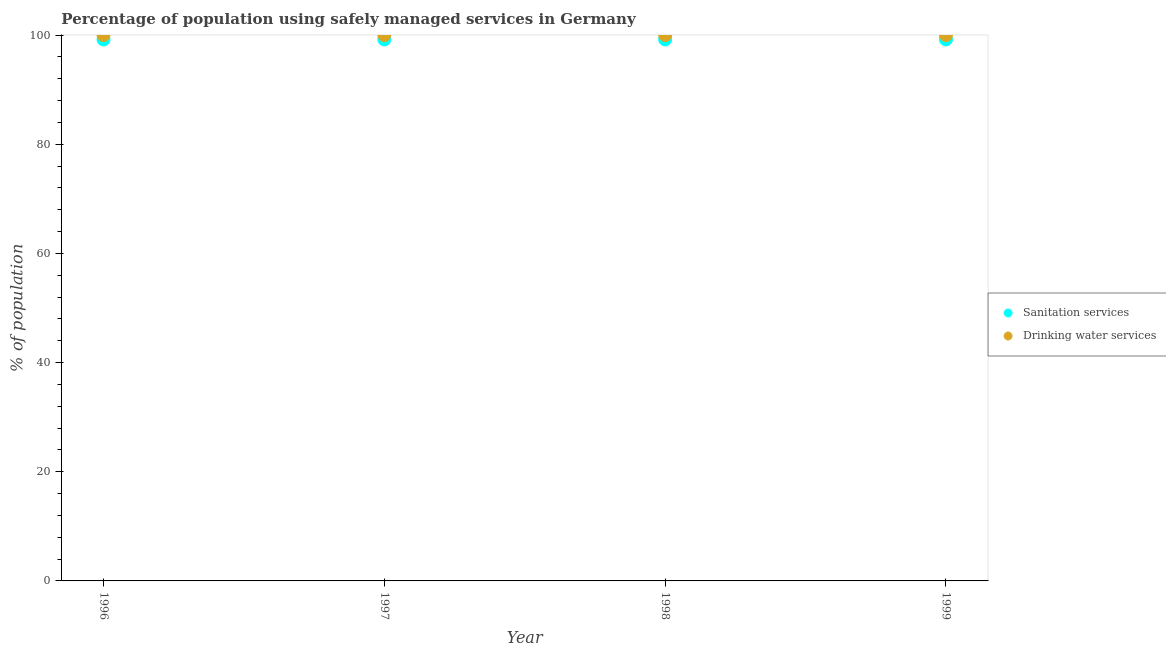What is the percentage of population who used sanitation services in 1998?
Your response must be concise. 99.2. Across all years, what is the maximum percentage of population who used drinking water services?
Your response must be concise. 100. Across all years, what is the minimum percentage of population who used sanitation services?
Make the answer very short. 99.2. What is the total percentage of population who used drinking water services in the graph?
Your answer should be very brief. 400. What is the difference between the percentage of population who used sanitation services in 1998 and that in 1999?
Keep it short and to the point. 0. What is the difference between the percentage of population who used drinking water services in 1997 and the percentage of population who used sanitation services in 1996?
Keep it short and to the point. 0.8. What is the average percentage of population who used sanitation services per year?
Give a very brief answer. 99.2. In the year 1997, what is the difference between the percentage of population who used sanitation services and percentage of population who used drinking water services?
Give a very brief answer. -0.8. In how many years, is the percentage of population who used sanitation services greater than 68 %?
Keep it short and to the point. 4. What is the ratio of the percentage of population who used drinking water services in 1998 to that in 1999?
Your answer should be very brief. 1. Is the percentage of population who used drinking water services in 1996 less than that in 1997?
Ensure brevity in your answer.  No. Is the percentage of population who used drinking water services strictly greater than the percentage of population who used sanitation services over the years?
Make the answer very short. Yes. Is the percentage of population who used drinking water services strictly less than the percentage of population who used sanitation services over the years?
Your answer should be compact. No. How many years are there in the graph?
Give a very brief answer. 4. What is the difference between two consecutive major ticks on the Y-axis?
Your response must be concise. 20. Does the graph contain any zero values?
Your answer should be very brief. No. How many legend labels are there?
Your answer should be compact. 2. What is the title of the graph?
Offer a very short reply. Percentage of population using safely managed services in Germany. Does "National Tourists" appear as one of the legend labels in the graph?
Ensure brevity in your answer.  No. What is the label or title of the Y-axis?
Keep it short and to the point. % of population. What is the % of population of Sanitation services in 1996?
Keep it short and to the point. 99.2. What is the % of population in Drinking water services in 1996?
Offer a very short reply. 100. What is the % of population of Sanitation services in 1997?
Provide a short and direct response. 99.2. What is the % of population of Sanitation services in 1998?
Your response must be concise. 99.2. What is the % of population in Sanitation services in 1999?
Offer a very short reply. 99.2. What is the % of population of Drinking water services in 1999?
Give a very brief answer. 100. Across all years, what is the maximum % of population in Sanitation services?
Keep it short and to the point. 99.2. Across all years, what is the maximum % of population of Drinking water services?
Your answer should be very brief. 100. Across all years, what is the minimum % of population in Sanitation services?
Your response must be concise. 99.2. What is the total % of population in Sanitation services in the graph?
Give a very brief answer. 396.8. What is the total % of population of Drinking water services in the graph?
Ensure brevity in your answer.  400. What is the difference between the % of population of Sanitation services in 1996 and that in 1997?
Keep it short and to the point. 0. What is the difference between the % of population of Drinking water services in 1996 and that in 1997?
Make the answer very short. 0. What is the difference between the % of population of Sanitation services in 1996 and that in 1998?
Ensure brevity in your answer.  0. What is the difference between the % of population in Drinking water services in 1996 and that in 1998?
Your answer should be compact. 0. What is the difference between the % of population in Sanitation services in 1996 and that in 1999?
Provide a short and direct response. 0. What is the difference between the % of population of Drinking water services in 1997 and that in 1998?
Your answer should be compact. 0. What is the difference between the % of population of Drinking water services in 1997 and that in 1999?
Provide a short and direct response. 0. What is the difference between the % of population of Sanitation services in 1998 and that in 1999?
Provide a short and direct response. 0. What is the difference between the % of population in Sanitation services in 1996 and the % of population in Drinking water services in 1997?
Give a very brief answer. -0.8. What is the difference between the % of population of Sanitation services in 1997 and the % of population of Drinking water services in 1999?
Provide a succinct answer. -0.8. What is the average % of population in Sanitation services per year?
Provide a short and direct response. 99.2. What is the average % of population in Drinking water services per year?
Offer a very short reply. 100. In the year 1997, what is the difference between the % of population in Sanitation services and % of population in Drinking water services?
Ensure brevity in your answer.  -0.8. In the year 1998, what is the difference between the % of population in Sanitation services and % of population in Drinking water services?
Ensure brevity in your answer.  -0.8. In the year 1999, what is the difference between the % of population of Sanitation services and % of population of Drinking water services?
Offer a very short reply. -0.8. What is the ratio of the % of population in Sanitation services in 1996 to that in 1998?
Give a very brief answer. 1. What is the ratio of the % of population of Sanitation services in 1997 to that in 1998?
Your response must be concise. 1. What is the ratio of the % of population of Drinking water services in 1997 to that in 1999?
Your response must be concise. 1. What is the ratio of the % of population of Sanitation services in 1998 to that in 1999?
Your answer should be very brief. 1. What is the ratio of the % of population in Drinking water services in 1998 to that in 1999?
Ensure brevity in your answer.  1. What is the difference between the highest and the second highest % of population in Sanitation services?
Give a very brief answer. 0. What is the difference between the highest and the lowest % of population of Sanitation services?
Make the answer very short. 0. 